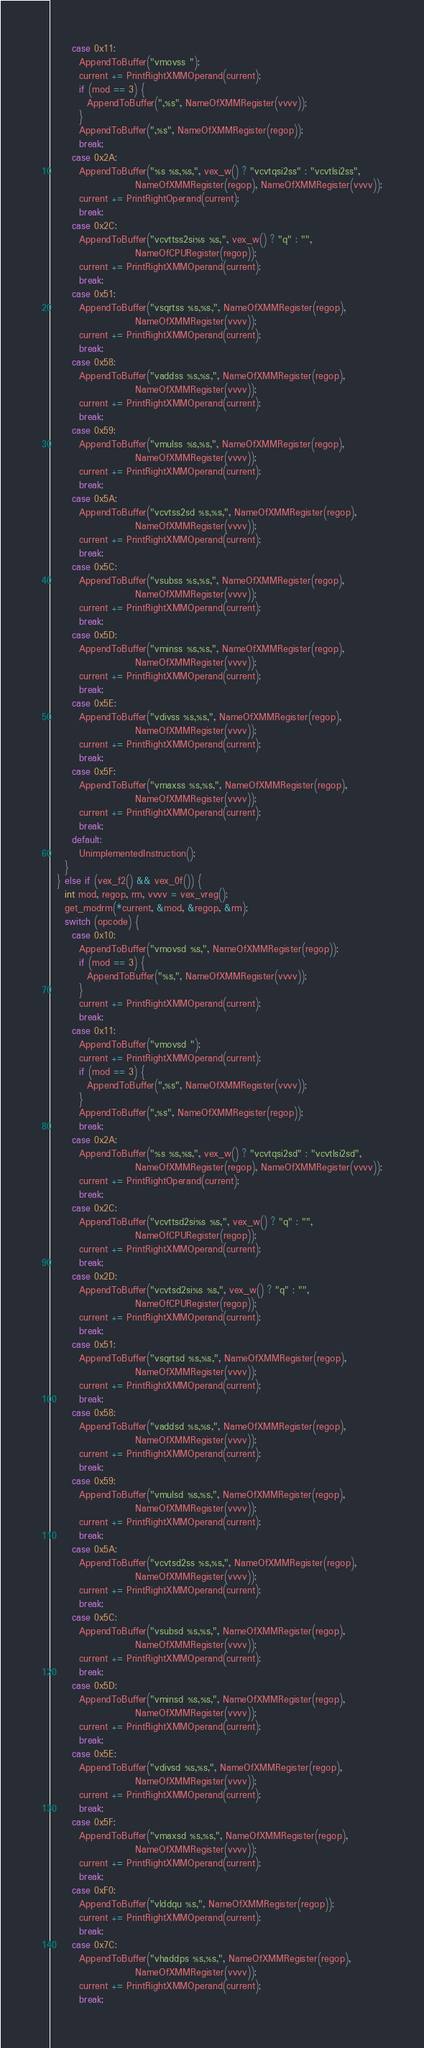<code> <loc_0><loc_0><loc_500><loc_500><_C++_>      case 0x11:
        AppendToBuffer("vmovss ");
        current += PrintRightXMMOperand(current);
        if (mod == 3) {
          AppendToBuffer(",%s", NameOfXMMRegister(vvvv));
        }
        AppendToBuffer(",%s", NameOfXMMRegister(regop));
        break;
      case 0x2A:
        AppendToBuffer("%s %s,%s,", vex_w() ? "vcvtqsi2ss" : "vcvtlsi2ss",
                       NameOfXMMRegister(regop), NameOfXMMRegister(vvvv));
        current += PrintRightOperand(current);
        break;
      case 0x2C:
        AppendToBuffer("vcvttss2si%s %s,", vex_w() ? "q" : "",
                       NameOfCPURegister(regop));
        current += PrintRightXMMOperand(current);
        break;
      case 0x51:
        AppendToBuffer("vsqrtss %s,%s,", NameOfXMMRegister(regop),
                       NameOfXMMRegister(vvvv));
        current += PrintRightXMMOperand(current);
        break;
      case 0x58:
        AppendToBuffer("vaddss %s,%s,", NameOfXMMRegister(regop),
                       NameOfXMMRegister(vvvv));
        current += PrintRightXMMOperand(current);
        break;
      case 0x59:
        AppendToBuffer("vmulss %s,%s,", NameOfXMMRegister(regop),
                       NameOfXMMRegister(vvvv));
        current += PrintRightXMMOperand(current);
        break;
      case 0x5A:
        AppendToBuffer("vcvtss2sd %s,%s,", NameOfXMMRegister(regop),
                       NameOfXMMRegister(vvvv));
        current += PrintRightXMMOperand(current);
        break;
      case 0x5C:
        AppendToBuffer("vsubss %s,%s,", NameOfXMMRegister(regop),
                       NameOfXMMRegister(vvvv));
        current += PrintRightXMMOperand(current);
        break;
      case 0x5D:
        AppendToBuffer("vminss %s,%s,", NameOfXMMRegister(regop),
                       NameOfXMMRegister(vvvv));
        current += PrintRightXMMOperand(current);
        break;
      case 0x5E:
        AppendToBuffer("vdivss %s,%s,", NameOfXMMRegister(regop),
                       NameOfXMMRegister(vvvv));
        current += PrintRightXMMOperand(current);
        break;
      case 0x5F:
        AppendToBuffer("vmaxss %s,%s,", NameOfXMMRegister(regop),
                       NameOfXMMRegister(vvvv));
        current += PrintRightXMMOperand(current);
        break;
      default:
        UnimplementedInstruction();
    }
  } else if (vex_f2() && vex_0f()) {
    int mod, regop, rm, vvvv = vex_vreg();
    get_modrm(*current, &mod, &regop, &rm);
    switch (opcode) {
      case 0x10:
        AppendToBuffer("vmovsd %s,", NameOfXMMRegister(regop));
        if (mod == 3) {
          AppendToBuffer("%s,", NameOfXMMRegister(vvvv));
        }
        current += PrintRightXMMOperand(current);
        break;
      case 0x11:
        AppendToBuffer("vmovsd ");
        current += PrintRightXMMOperand(current);
        if (mod == 3) {
          AppendToBuffer(",%s", NameOfXMMRegister(vvvv));
        }
        AppendToBuffer(",%s", NameOfXMMRegister(regop));
        break;
      case 0x2A:
        AppendToBuffer("%s %s,%s,", vex_w() ? "vcvtqsi2sd" : "vcvtlsi2sd",
                       NameOfXMMRegister(regop), NameOfXMMRegister(vvvv));
        current += PrintRightOperand(current);
        break;
      case 0x2C:
        AppendToBuffer("vcvttsd2si%s %s,", vex_w() ? "q" : "",
                       NameOfCPURegister(regop));
        current += PrintRightXMMOperand(current);
        break;
      case 0x2D:
        AppendToBuffer("vcvtsd2si%s %s,", vex_w() ? "q" : "",
                       NameOfCPURegister(regop));
        current += PrintRightXMMOperand(current);
        break;
      case 0x51:
        AppendToBuffer("vsqrtsd %s,%s,", NameOfXMMRegister(regop),
                       NameOfXMMRegister(vvvv));
        current += PrintRightXMMOperand(current);
        break;
      case 0x58:
        AppendToBuffer("vaddsd %s,%s,", NameOfXMMRegister(regop),
                       NameOfXMMRegister(vvvv));
        current += PrintRightXMMOperand(current);
        break;
      case 0x59:
        AppendToBuffer("vmulsd %s,%s,", NameOfXMMRegister(regop),
                       NameOfXMMRegister(vvvv));
        current += PrintRightXMMOperand(current);
        break;
      case 0x5A:
        AppendToBuffer("vcvtsd2ss %s,%s,", NameOfXMMRegister(regop),
                       NameOfXMMRegister(vvvv));
        current += PrintRightXMMOperand(current);
        break;
      case 0x5C:
        AppendToBuffer("vsubsd %s,%s,", NameOfXMMRegister(regop),
                       NameOfXMMRegister(vvvv));
        current += PrintRightXMMOperand(current);
        break;
      case 0x5D:
        AppendToBuffer("vminsd %s,%s,", NameOfXMMRegister(regop),
                       NameOfXMMRegister(vvvv));
        current += PrintRightXMMOperand(current);
        break;
      case 0x5E:
        AppendToBuffer("vdivsd %s,%s,", NameOfXMMRegister(regop),
                       NameOfXMMRegister(vvvv));
        current += PrintRightXMMOperand(current);
        break;
      case 0x5F:
        AppendToBuffer("vmaxsd %s,%s,", NameOfXMMRegister(regop),
                       NameOfXMMRegister(vvvv));
        current += PrintRightXMMOperand(current);
        break;
      case 0xF0:
        AppendToBuffer("vlddqu %s,", NameOfXMMRegister(regop));
        current += PrintRightXMMOperand(current);
        break;
      case 0x7C:
        AppendToBuffer("vhaddps %s,%s,", NameOfXMMRegister(regop),
                       NameOfXMMRegister(vvvv));
        current += PrintRightXMMOperand(current);
        break;</code> 